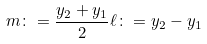<formula> <loc_0><loc_0><loc_500><loc_500>m \colon = \frac { y _ { 2 } + y _ { 1 } } 2 \ell \colon = y _ { 2 } - y _ { 1 }</formula> 